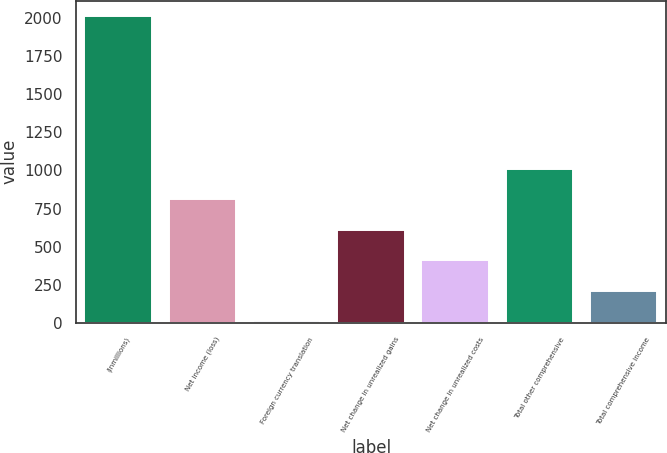Convert chart. <chart><loc_0><loc_0><loc_500><loc_500><bar_chart><fcel>(inmillions)<fcel>Net income (loss)<fcel>Foreign currency translation<fcel>Net change in unrealized gains<fcel>Net change in unrealized costs<fcel>Total other comprehensive<fcel>Total comprehensive income<nl><fcel>2013<fcel>811.2<fcel>10<fcel>610.9<fcel>410.6<fcel>1011.5<fcel>210.3<nl></chart> 